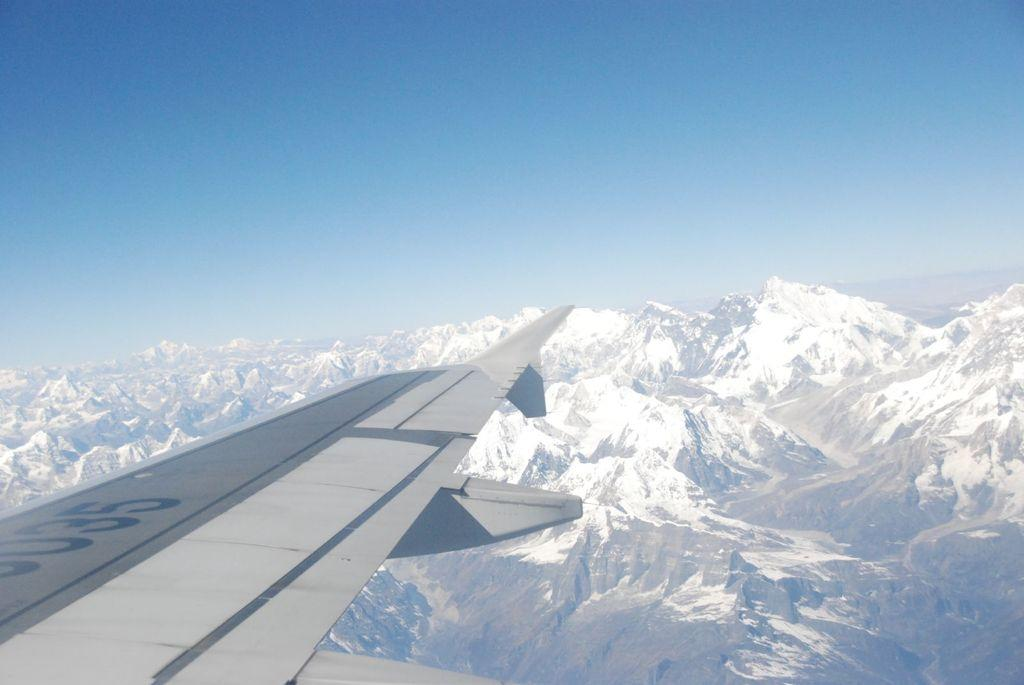Provide a one-sentence caption for the provided image. An airplane wing in the clouds that says 035 on it. 